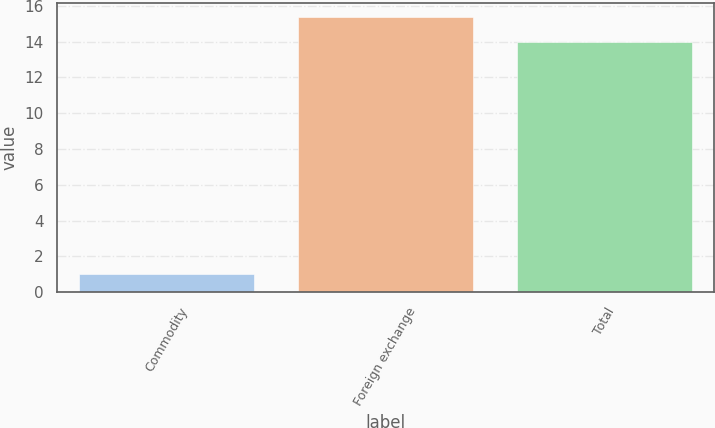Convert chart to OTSL. <chart><loc_0><loc_0><loc_500><loc_500><bar_chart><fcel>Commodity<fcel>Foreign exchange<fcel>Total<nl><fcel>1<fcel>15.4<fcel>14<nl></chart> 